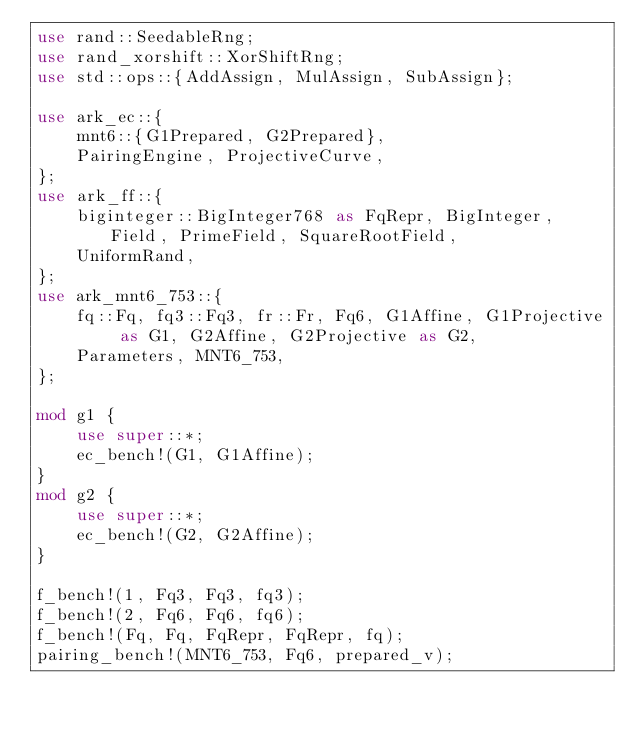<code> <loc_0><loc_0><loc_500><loc_500><_Rust_>use rand::SeedableRng;
use rand_xorshift::XorShiftRng;
use std::ops::{AddAssign, MulAssign, SubAssign};

use ark_ec::{
    mnt6::{G1Prepared, G2Prepared},
    PairingEngine, ProjectiveCurve,
};
use ark_ff::{
    biginteger::BigInteger768 as FqRepr, BigInteger, Field, PrimeField, SquareRootField,
    UniformRand,
};
use ark_mnt6_753::{
    fq::Fq, fq3::Fq3, fr::Fr, Fq6, G1Affine, G1Projective as G1, G2Affine, G2Projective as G2,
    Parameters, MNT6_753,
};

mod g1 {
    use super::*;
    ec_bench!(G1, G1Affine);
}
mod g2 {
    use super::*;
    ec_bench!(G2, G2Affine);
}

f_bench!(1, Fq3, Fq3, fq3);
f_bench!(2, Fq6, Fq6, fq6);
f_bench!(Fq, Fq, FqRepr, FqRepr, fq);
pairing_bench!(MNT6_753, Fq6, prepared_v);
</code> 